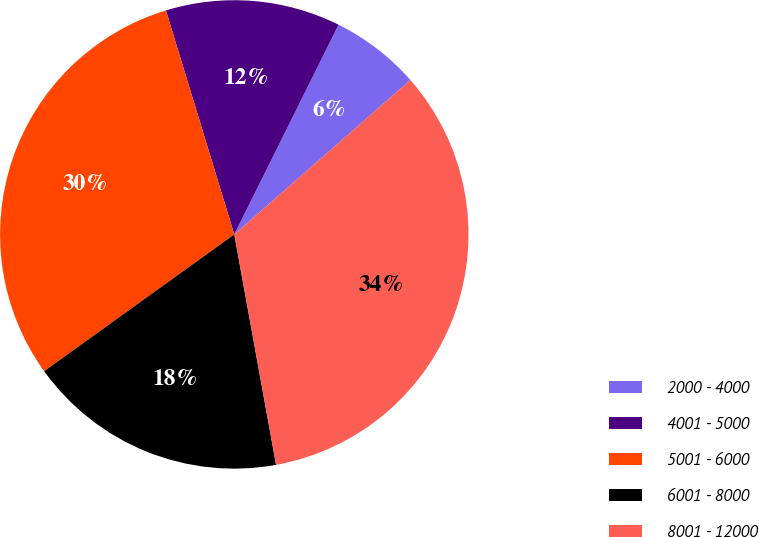Convert chart to OTSL. <chart><loc_0><loc_0><loc_500><loc_500><pie_chart><fcel>2000 - 4000<fcel>4001 - 5000<fcel>5001 - 6000<fcel>6001 - 8000<fcel>8001 - 12000<nl><fcel>6.2%<fcel>12.06%<fcel>30.21%<fcel>17.93%<fcel>33.6%<nl></chart> 